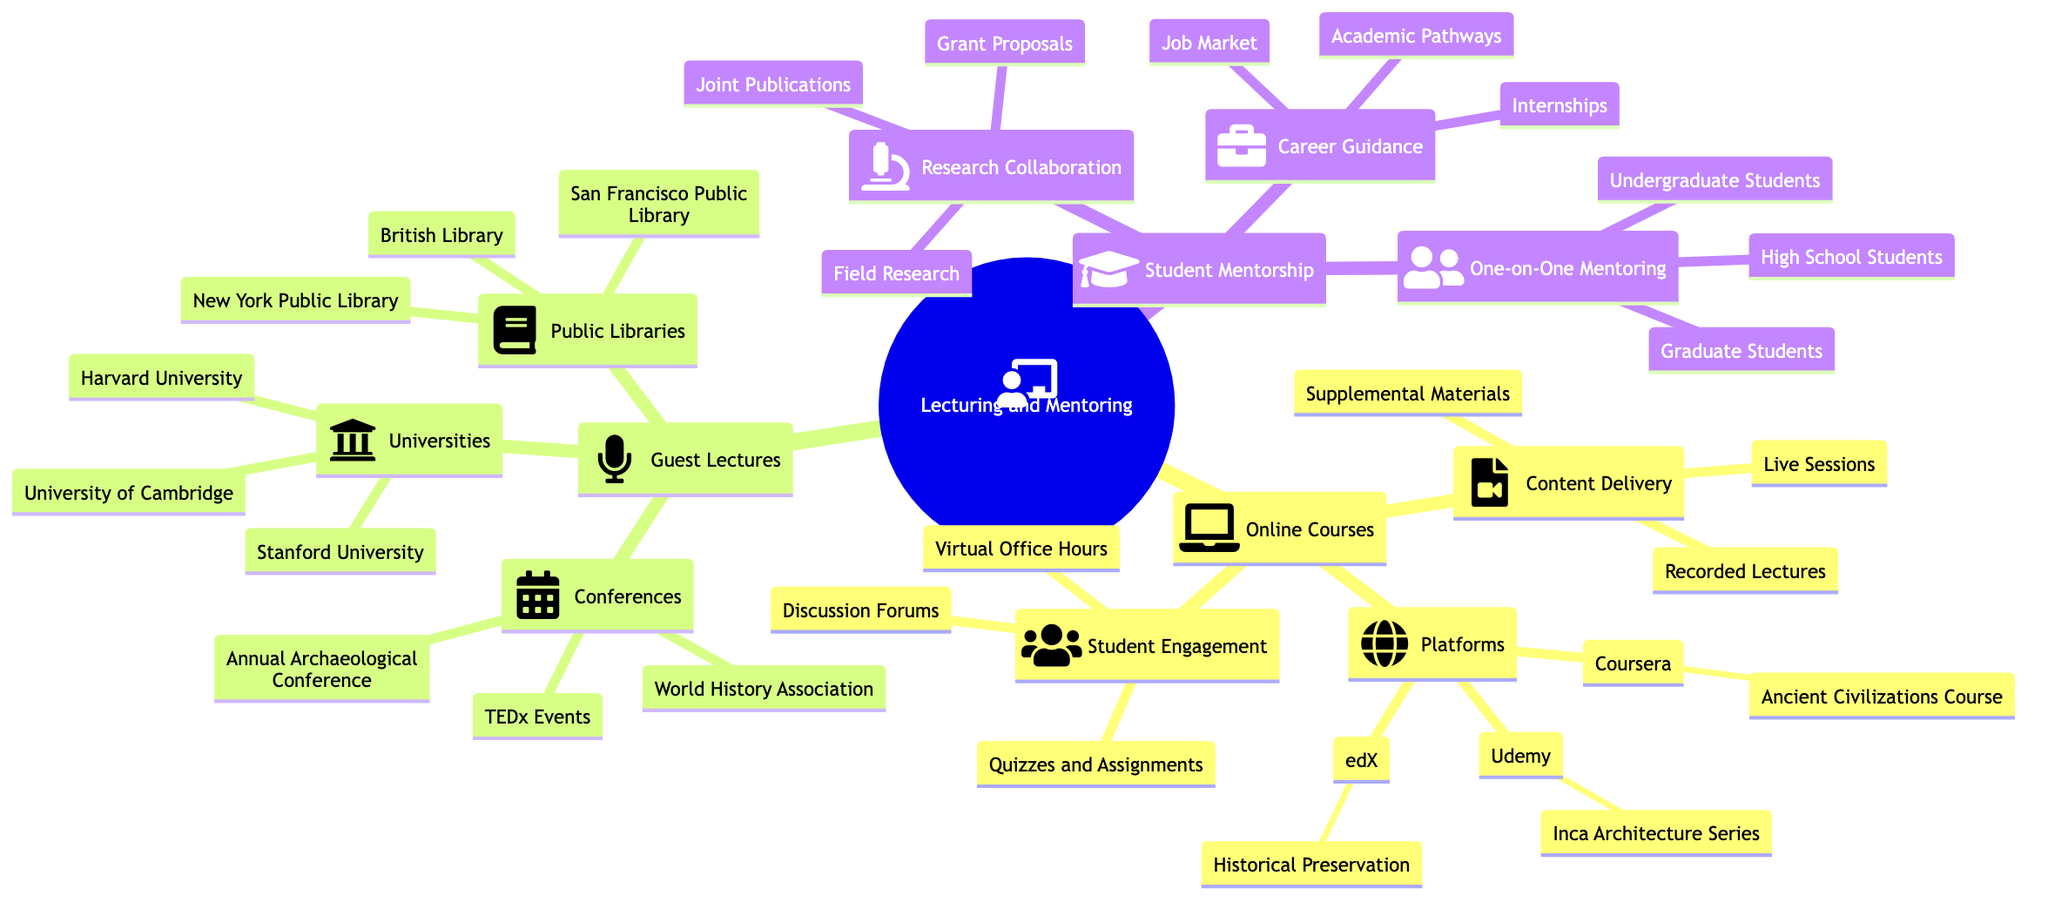What are the platforms listed under Online Courses? The diagram specifies three platforms under Online Courses: Coursera, Udemy, and edX, directly presented within the Platforms node.
Answer: Coursera, Udemy, edX How many main categories are there in the diagram? The main categories branching from the root node "Lecturing and Mentoring" are Online Courses, Guest Lectures, and Student Mentorship, resulting in three distinct categories.
Answer: 3 What kind of sessions are offered under Content Delivery? The Content Delivery node mentions three types of sessions: Live Sessions, Recorded Lectures, and Supplemental Materials, which are explicitly listed under this section.
Answer: Live Sessions, Recorded Lectures, Supplemental Materials Which universities are featured for Guest Lectures? The diagram lists Harvard University, University of Cambridge, and Stanford University under the Guest Lectures category, specifically in the Universities node.
Answer: Harvard University, University of Cambridge, Stanford University What is the focus of the course on Coursera? According to the diagram, the course on Coursera is focused on Ancient Civilizations and their Cultural Heritage, as stated within the Platforms section.
Answer: Ancient Civilizations and their Cultural Heritage How does Student Engagement promote community interaction? The Student Engagement node indicates that community interaction is promoted through Discussion Forums, which is clearly stated under this category.
Answer: Discussion Forums Which type of mentorship is indicated for high school students? The One-on-One Mentoring section mentions High School Students explicitly, identifying the mentorship opportunities available for this group.
Answer: Mentorship for history clubs and fairs What types of research collaboration are listed? Under the Research Collaboration node, there are three types: Joint Publications, Field Research, and Grant Proposals, each explicitly mentioned.
Answer: Joint Publications, Field Research, Grant Proposals What is the purpose of the Annual Archaeological Conference? The diagram notes that the purpose of the Annual Archaeological Conference is to provide a keynote on Machu Picchu's significance, as stated under the Conferences section of Guest Lectures.
Answer: Keynote on Machu Picchu's significance 